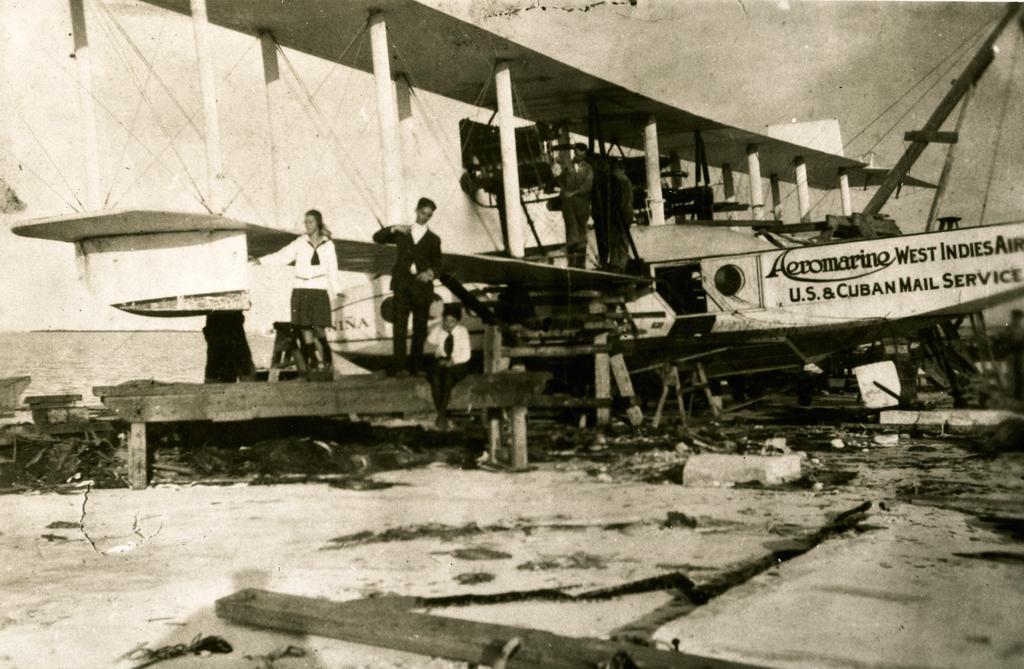Can you describe this image briefly? This is an old black and white image. I can see few people standing and a person sitting on a bench. There is a vintage aircraft. At the bottom of the image, there are few objects on the ground. 